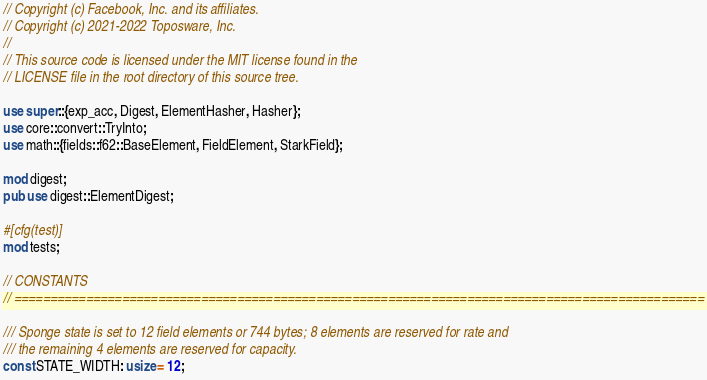<code> <loc_0><loc_0><loc_500><loc_500><_Rust_>// Copyright (c) Facebook, Inc. and its affiliates.
// Copyright (c) 2021-2022 Toposware, Inc.
//
// This source code is licensed under the MIT license found in the
// LICENSE file in the root directory of this source tree.

use super::{exp_acc, Digest, ElementHasher, Hasher};
use core::convert::TryInto;
use math::{fields::f62::BaseElement, FieldElement, StarkField};

mod digest;
pub use digest::ElementDigest;

#[cfg(test)]
mod tests;

// CONSTANTS
// ================================================================================================

/// Sponge state is set to 12 field elements or 744 bytes; 8 elements are reserved for rate and
/// the remaining 4 elements are reserved for capacity.
const STATE_WIDTH: usize = 12;</code> 